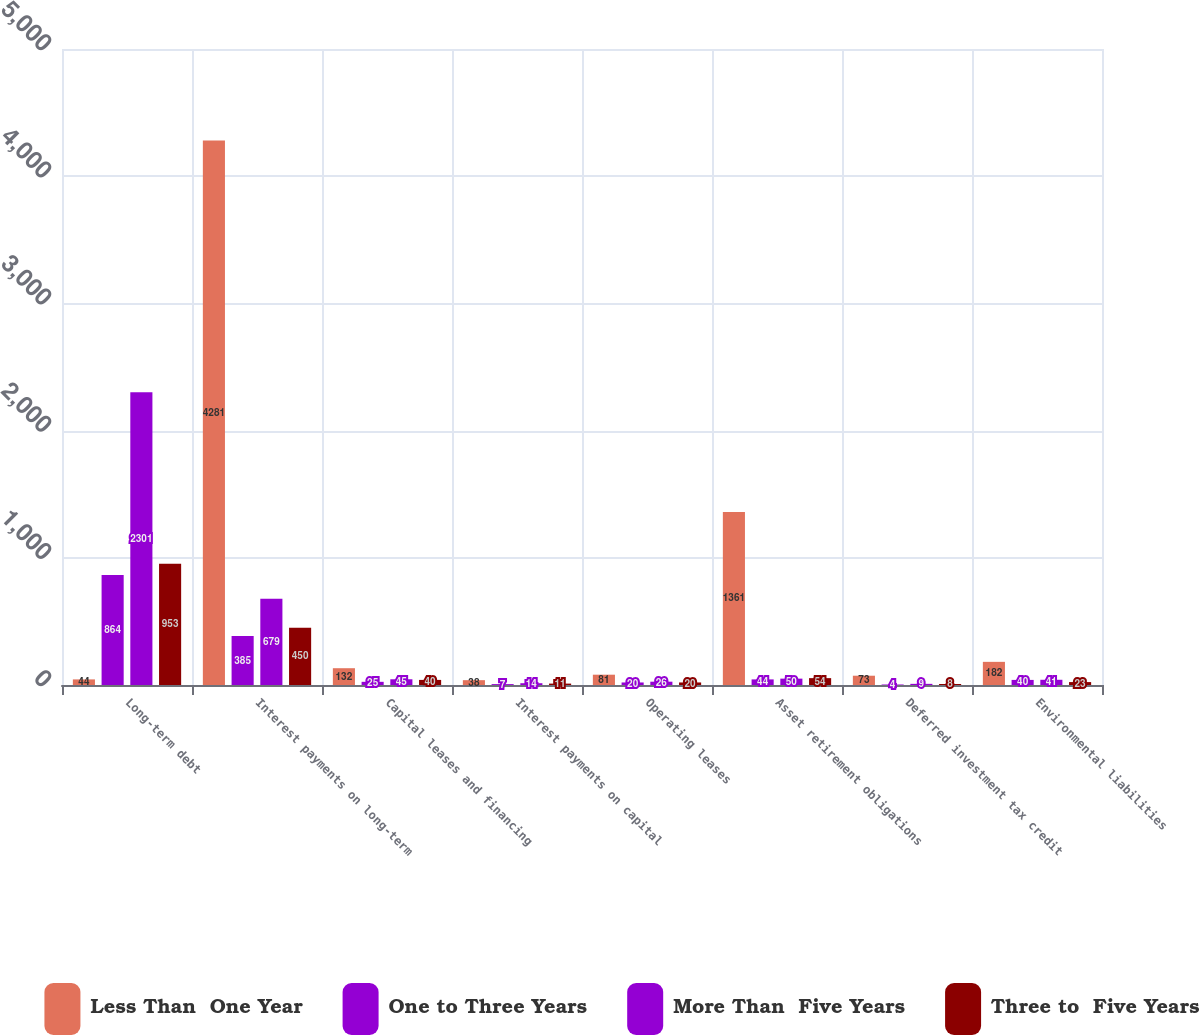Convert chart to OTSL. <chart><loc_0><loc_0><loc_500><loc_500><stacked_bar_chart><ecel><fcel>Long-term debt<fcel>Interest payments on long-term<fcel>Capital leases and financing<fcel>Interest payments on capital<fcel>Operating leases<fcel>Asset retirement obligations<fcel>Deferred investment tax credit<fcel>Environmental liabilities<nl><fcel>Less Than  One Year<fcel>44<fcel>4281<fcel>132<fcel>38<fcel>81<fcel>1361<fcel>73<fcel>182<nl><fcel>One to Three Years<fcel>864<fcel>385<fcel>25<fcel>7<fcel>20<fcel>44<fcel>4<fcel>40<nl><fcel>More Than  Five Years<fcel>2301<fcel>679<fcel>45<fcel>14<fcel>26<fcel>50<fcel>9<fcel>41<nl><fcel>Three to  Five Years<fcel>953<fcel>450<fcel>40<fcel>11<fcel>20<fcel>54<fcel>8<fcel>23<nl></chart> 